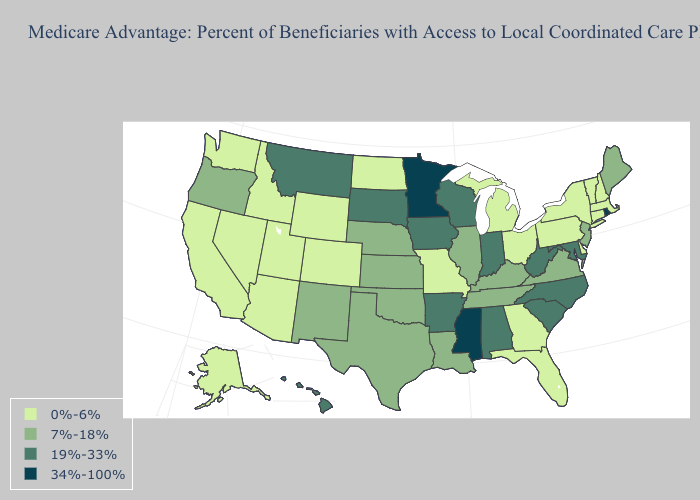Among the states that border Kentucky , does West Virginia have the highest value?
Short answer required. Yes. Name the states that have a value in the range 0%-6%?
Concise answer only. Alaska, Arizona, California, Colorado, Connecticut, Delaware, Florida, Georgia, Idaho, Massachusetts, Michigan, Missouri, North Dakota, New Hampshire, Nevada, New York, Ohio, Pennsylvania, Utah, Vermont, Washington, Wyoming. What is the highest value in states that border Alabama?
Give a very brief answer. 34%-100%. What is the value of Wisconsin?
Quick response, please. 19%-33%. What is the value of Michigan?
Give a very brief answer. 0%-6%. Among the states that border Maryland , which have the highest value?
Keep it brief. West Virginia. What is the value of Illinois?
Answer briefly. 7%-18%. What is the lowest value in states that border Minnesota?
Keep it brief. 0%-6%. Does Connecticut have the same value as Kansas?
Short answer required. No. Does Louisiana have a lower value than South Dakota?
Be succinct. Yes. What is the highest value in states that border Oregon?
Keep it brief. 0%-6%. What is the value of New York?
Write a very short answer. 0%-6%. Among the states that border Wyoming , which have the highest value?
Give a very brief answer. Montana, South Dakota. Among the states that border Pennsylvania , does Delaware have the lowest value?
Be succinct. Yes. 